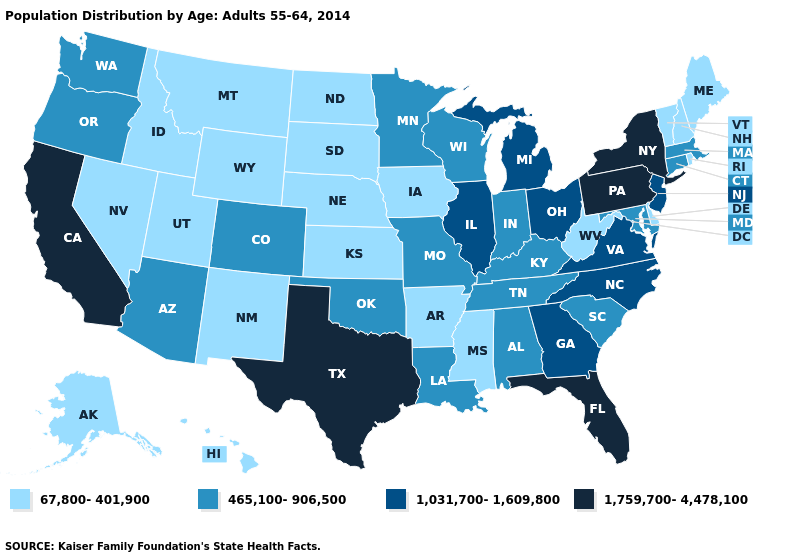Among the states that border Michigan , does Ohio have the lowest value?
Quick response, please. No. Does the first symbol in the legend represent the smallest category?
Keep it brief. Yes. Does the map have missing data?
Answer briefly. No. What is the lowest value in the USA?
Write a very short answer. 67,800-401,900. Does New Mexico have a higher value than Connecticut?
Quick response, please. No. Does the first symbol in the legend represent the smallest category?
Answer briefly. Yes. Which states have the highest value in the USA?
Be succinct. California, Florida, New York, Pennsylvania, Texas. Does Kansas have the lowest value in the USA?
Short answer required. Yes. How many symbols are there in the legend?
Keep it brief. 4. What is the highest value in states that border Missouri?
Answer briefly. 1,031,700-1,609,800. What is the value of Alabama?
Concise answer only. 465,100-906,500. Name the states that have a value in the range 465,100-906,500?
Write a very short answer. Alabama, Arizona, Colorado, Connecticut, Indiana, Kentucky, Louisiana, Maryland, Massachusetts, Minnesota, Missouri, Oklahoma, Oregon, South Carolina, Tennessee, Washington, Wisconsin. Among the states that border Illinois , does Kentucky have the highest value?
Short answer required. Yes. What is the highest value in the USA?
Answer briefly. 1,759,700-4,478,100. What is the highest value in states that border Oklahoma?
Answer briefly. 1,759,700-4,478,100. 